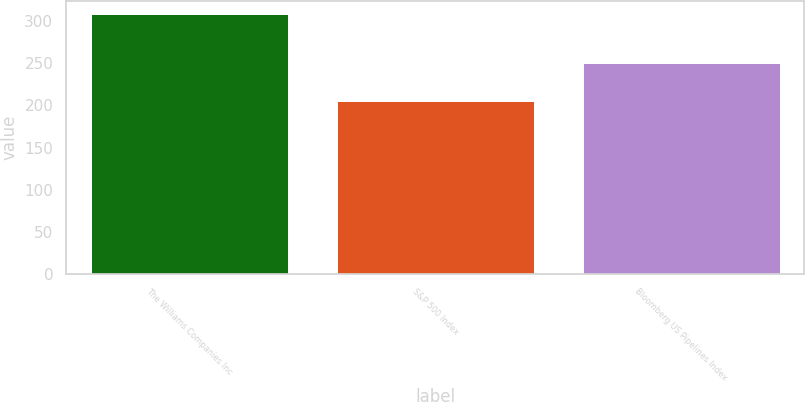Convert chart. <chart><loc_0><loc_0><loc_500><loc_500><bar_chart><fcel>The Williams Companies Inc<fcel>S&P 500 Index<fcel>Bloomberg US Pipelines Index<nl><fcel>308.4<fcel>205<fcel>250.1<nl></chart> 